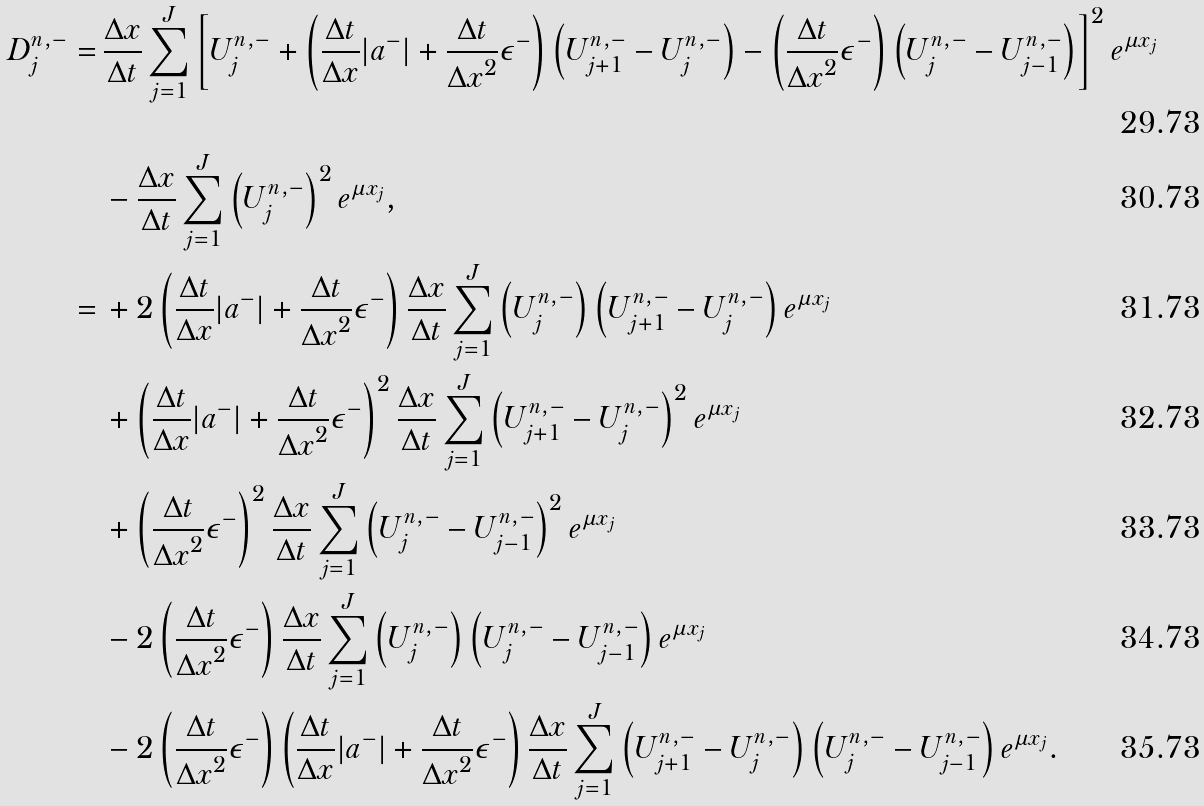Convert formula to latex. <formula><loc_0><loc_0><loc_500><loc_500>D _ { j } ^ { n , - } = & \, \frac { \Delta x } { \Delta t } \sum _ { j = 1 } ^ { J } \left [ U _ { j } ^ { n , - } + \left ( \frac { \Delta t } { \Delta x } | a ^ { - } | + \frac { \Delta t } { { \Delta x } ^ { 2 } } \epsilon ^ { - } \right ) \left ( U _ { j + 1 } ^ { n , - } - U _ { j } ^ { n , - } \right ) - \left ( \frac { \Delta t } { { \Delta x } ^ { 2 } } \epsilon ^ { - } \right ) \left ( U _ { j } ^ { n , - } - U _ { j - 1 } ^ { n , - } \right ) \right ] ^ { 2 } e ^ { \mu x _ { j } } \\ & \, - \frac { \Delta x } { \Delta t } \sum _ { j = 1 } ^ { J } \left ( U _ { j } ^ { n , - } \right ) ^ { 2 } e ^ { \mu x _ { j } } , \\ = & \, + 2 \left ( \frac { \Delta t } { \Delta x } | a ^ { - } | + \frac { \Delta t } { { \Delta x } ^ { 2 } } \epsilon ^ { - } \right ) \frac { \Delta x } { \Delta t } \sum _ { j = 1 } ^ { J } \left ( U _ { j } ^ { n , - } \right ) \left ( U _ { j + 1 } ^ { n , - } - U _ { j } ^ { n , - } \right ) e ^ { \mu x _ { j } } \\ & \, + \left ( \frac { \Delta t } { \Delta x } | a ^ { - } | + \frac { \Delta t } { { \Delta x } ^ { 2 } } \epsilon ^ { - } \right ) ^ { 2 } \frac { \Delta x } { \Delta t } \sum _ { j = 1 } ^ { J } \left ( U _ { j + 1 } ^ { n , - } - U _ { j } ^ { n , - } \right ) ^ { 2 } e ^ { \mu x _ { j } } \\ & \, + \left ( \frac { \Delta t } { { \Delta x } ^ { 2 } } \epsilon ^ { - } \right ) ^ { 2 } \frac { \Delta x } { \Delta t } \sum _ { j = 1 } ^ { J } \left ( U _ { j } ^ { n , - } - U _ { j - 1 } ^ { n , - } \right ) ^ { 2 } e ^ { \mu x _ { j } } \\ & \, - 2 \left ( \frac { \Delta t } { { \Delta x } ^ { 2 } } \epsilon ^ { - } \right ) \frac { \Delta x } { \Delta t } \sum _ { j = 1 } ^ { J } \left ( U _ { j } ^ { n , - } \right ) \left ( U _ { j } ^ { n , - } - U _ { j - 1 } ^ { n , - } \right ) e ^ { \mu x _ { j } } \\ & \, - 2 \left ( \frac { \Delta t } { { \Delta x } ^ { 2 } } \epsilon ^ { - } \right ) \left ( \frac { \Delta t } { \Delta x } | a ^ { - } | + \frac { \Delta t } { { \Delta x } ^ { 2 } } \epsilon ^ { - } \right ) \frac { \Delta x } { \Delta t } \sum _ { j = 1 } ^ { J } \left ( U _ { j + 1 } ^ { n , - } - U _ { j } ^ { n , - } \right ) \left ( U _ { j } ^ { n , - } - U _ { j - 1 } ^ { n , - } \right ) e ^ { \mu x _ { j } } .</formula> 